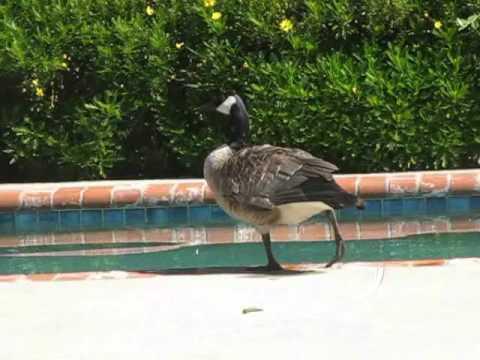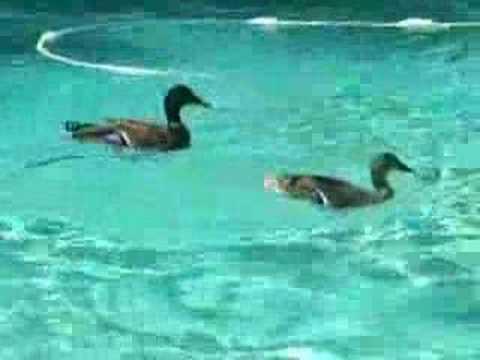The first image is the image on the left, the second image is the image on the right. Examine the images to the left and right. Is the description "Each image shows exactly one bird floating on water, and at least one of the birds is a Canadian goose." accurate? Answer yes or no. No. The first image is the image on the left, the second image is the image on the right. For the images shown, is this caption "The right image contains at least two ducks." true? Answer yes or no. Yes. 